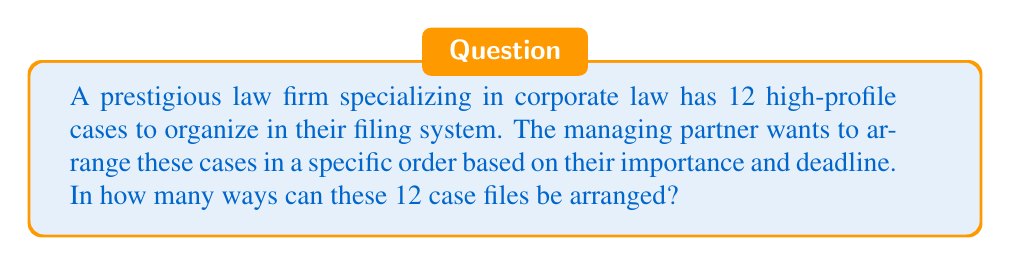Provide a solution to this math problem. To solve this problem, we need to understand that this is a permutation question. We are arranging all 12 case files in a specific order, where the order matters.

The formula for permutations of n distinct objects is:

$$P(n) = n!$$

Where n! (n factorial) is the product of all positive integers less than or equal to n.

In this case, we have 12 case files, so n = 12.

Therefore, the number of ways to arrange these files is:

$$P(12) = 12!$$

Let's calculate this:

$$\begin{align}
12! &= 12 \times 11 \times 10 \times 9 \times 8 \times 7 \times 6 \times 5 \times 4 \times 3 \times 2 \times 1 \\
&= 479,001,600
\end{align}$$

This large number demonstrates the importance of having an efficient filing system in a prestigious law firm, as there are numerous ways to organize these high-profile cases.
Answer: $479,001,600$ ways 